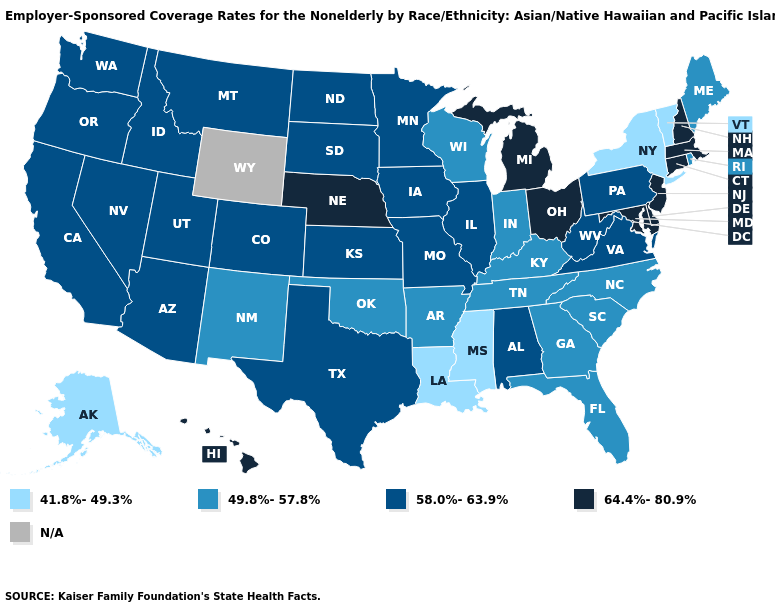What is the value of Maine?
Give a very brief answer. 49.8%-57.8%. Does Hawaii have the lowest value in the West?
Give a very brief answer. No. Name the states that have a value in the range 58.0%-63.9%?
Quick response, please. Alabama, Arizona, California, Colorado, Idaho, Illinois, Iowa, Kansas, Minnesota, Missouri, Montana, Nevada, North Dakota, Oregon, Pennsylvania, South Dakota, Texas, Utah, Virginia, Washington, West Virginia. Name the states that have a value in the range 41.8%-49.3%?
Quick response, please. Alaska, Louisiana, Mississippi, New York, Vermont. What is the lowest value in the USA?
Be succinct. 41.8%-49.3%. Name the states that have a value in the range 64.4%-80.9%?
Short answer required. Connecticut, Delaware, Hawaii, Maryland, Massachusetts, Michigan, Nebraska, New Hampshire, New Jersey, Ohio. What is the lowest value in the West?
Write a very short answer. 41.8%-49.3%. Name the states that have a value in the range 58.0%-63.9%?
Concise answer only. Alabama, Arizona, California, Colorado, Idaho, Illinois, Iowa, Kansas, Minnesota, Missouri, Montana, Nevada, North Dakota, Oregon, Pennsylvania, South Dakota, Texas, Utah, Virginia, Washington, West Virginia. What is the lowest value in the West?
Concise answer only. 41.8%-49.3%. Name the states that have a value in the range 58.0%-63.9%?
Concise answer only. Alabama, Arizona, California, Colorado, Idaho, Illinois, Iowa, Kansas, Minnesota, Missouri, Montana, Nevada, North Dakota, Oregon, Pennsylvania, South Dakota, Texas, Utah, Virginia, Washington, West Virginia. What is the value of West Virginia?
Keep it brief. 58.0%-63.9%. What is the highest value in the West ?
Quick response, please. 64.4%-80.9%. Name the states that have a value in the range 58.0%-63.9%?
Short answer required. Alabama, Arizona, California, Colorado, Idaho, Illinois, Iowa, Kansas, Minnesota, Missouri, Montana, Nevada, North Dakota, Oregon, Pennsylvania, South Dakota, Texas, Utah, Virginia, Washington, West Virginia. Which states have the lowest value in the South?
Concise answer only. Louisiana, Mississippi. 